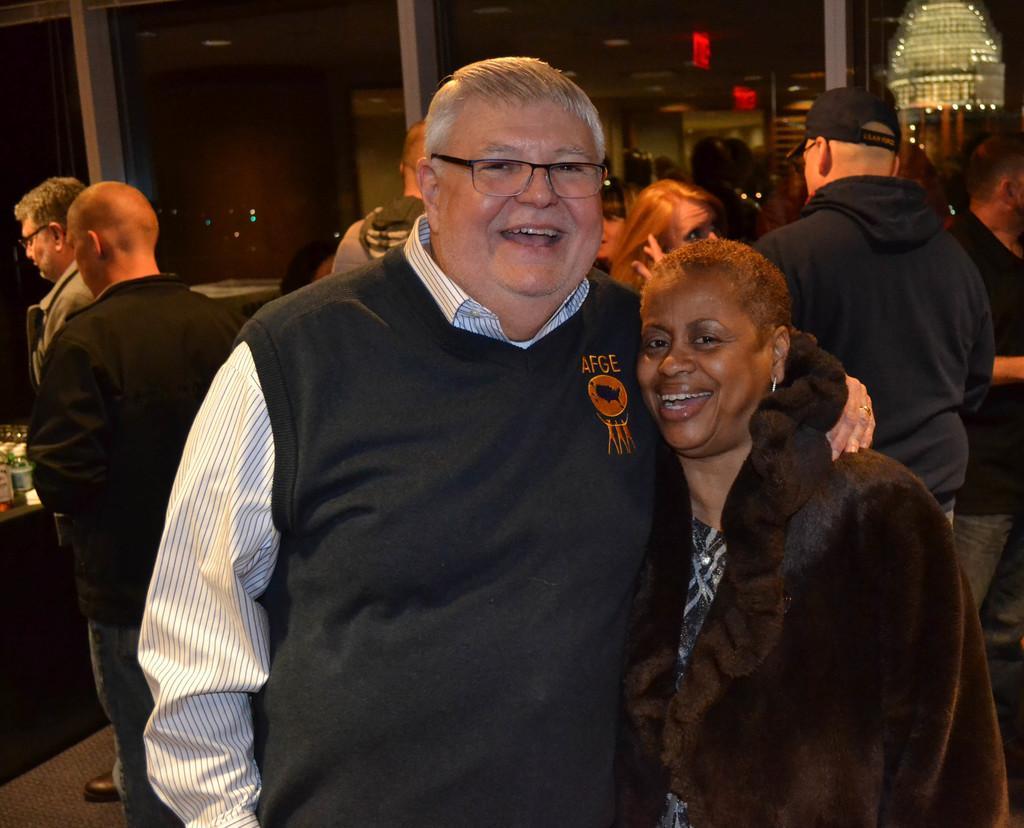Can you describe this image briefly? In the picture I can see some people are in the room, side there is a glass window, we can see table on which some bottles are placed. 